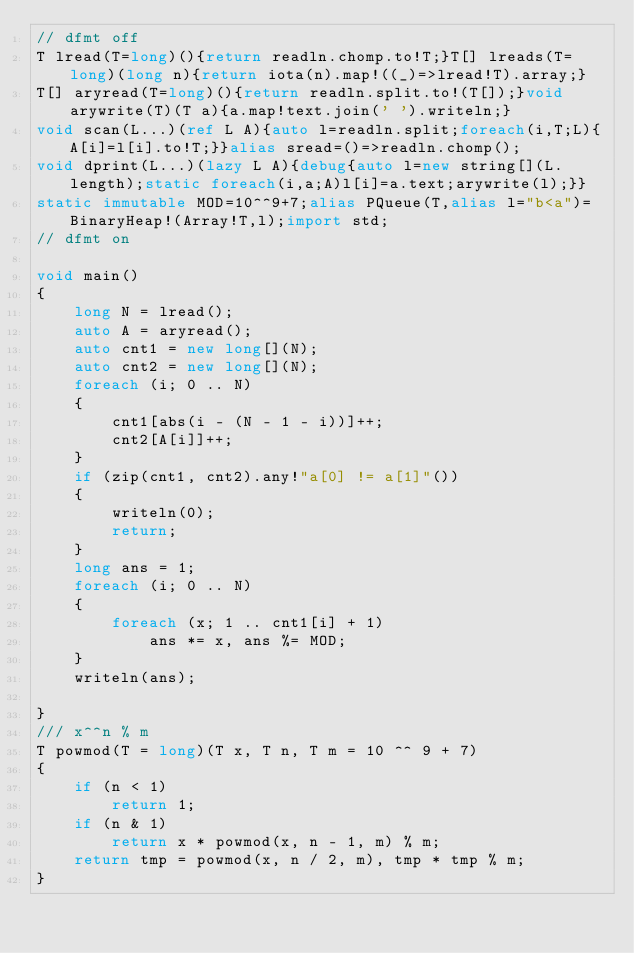Convert code to text. <code><loc_0><loc_0><loc_500><loc_500><_D_>// dfmt off
T lread(T=long)(){return readln.chomp.to!T;}T[] lreads(T=long)(long n){return iota(n).map!((_)=>lread!T).array;}
T[] aryread(T=long)(){return readln.split.to!(T[]);}void arywrite(T)(T a){a.map!text.join(' ').writeln;}
void scan(L...)(ref L A){auto l=readln.split;foreach(i,T;L){A[i]=l[i].to!T;}}alias sread=()=>readln.chomp();
void dprint(L...)(lazy L A){debug{auto l=new string[](L.length);static foreach(i,a;A)l[i]=a.text;arywrite(l);}}
static immutable MOD=10^^9+7;alias PQueue(T,alias l="b<a")=BinaryHeap!(Array!T,l);import std;
// dfmt on

void main()
{
    long N = lread();
    auto A = aryread();
    auto cnt1 = new long[](N);
    auto cnt2 = new long[](N);
    foreach (i; 0 .. N)
    {
        cnt1[abs(i - (N - 1 - i))]++;
        cnt2[A[i]]++;
    }
    if (zip(cnt1, cnt2).any!"a[0] != a[1]"())
    {
        writeln(0);
        return;
    }
    long ans = 1;
    foreach (i; 0 .. N)
    {
        foreach (x; 1 .. cnt1[i] + 1)
            ans *= x, ans %= MOD;
    }
    writeln(ans);

}
/// x^^n % m
T powmod(T = long)(T x, T n, T m = 10 ^^ 9 + 7)
{
    if (n < 1)
        return 1;
    if (n & 1)
        return x * powmod(x, n - 1, m) % m;
    return tmp = powmod(x, n / 2, m), tmp * tmp % m;
}
</code> 